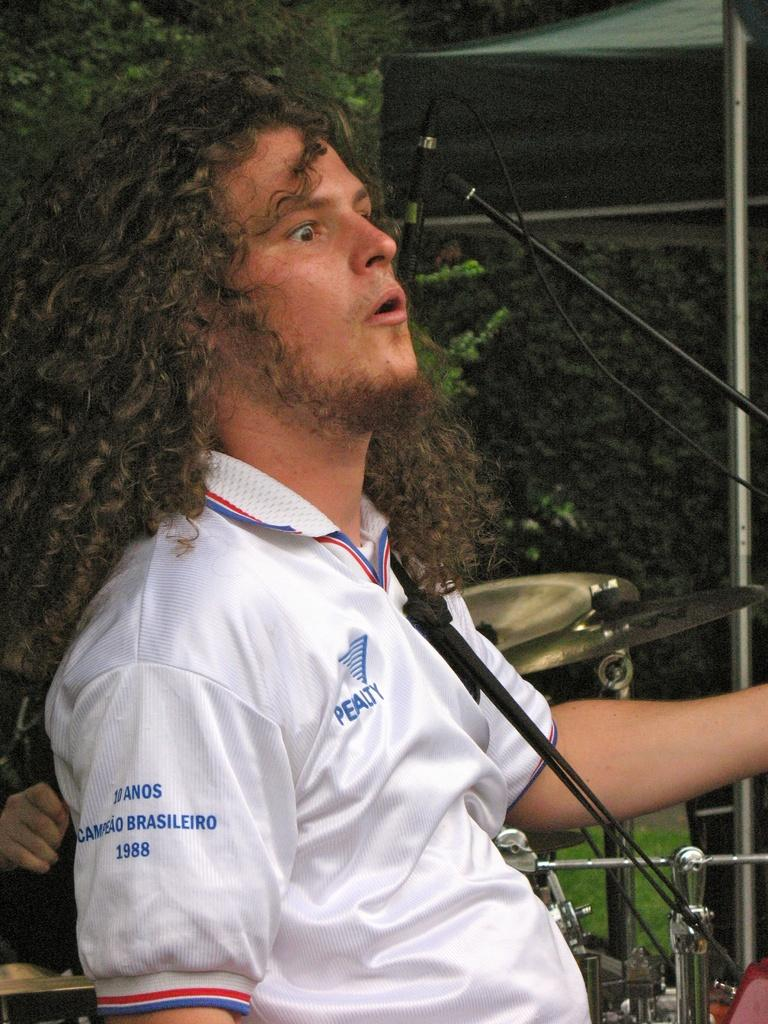Who or what is present in the image? There is a person in the image. What object is associated with the person in the image? There is a microphone (mike) in the image. What other items can be seen in the image? There are musical instruments in the image. What can be seen in the background of the image? There are trees in the background of the image. What type of hook is being used to play the musical instruments in the image? There is no hook present in the image; the musical instruments are being played by the person using their hands or other appropriate methods. 